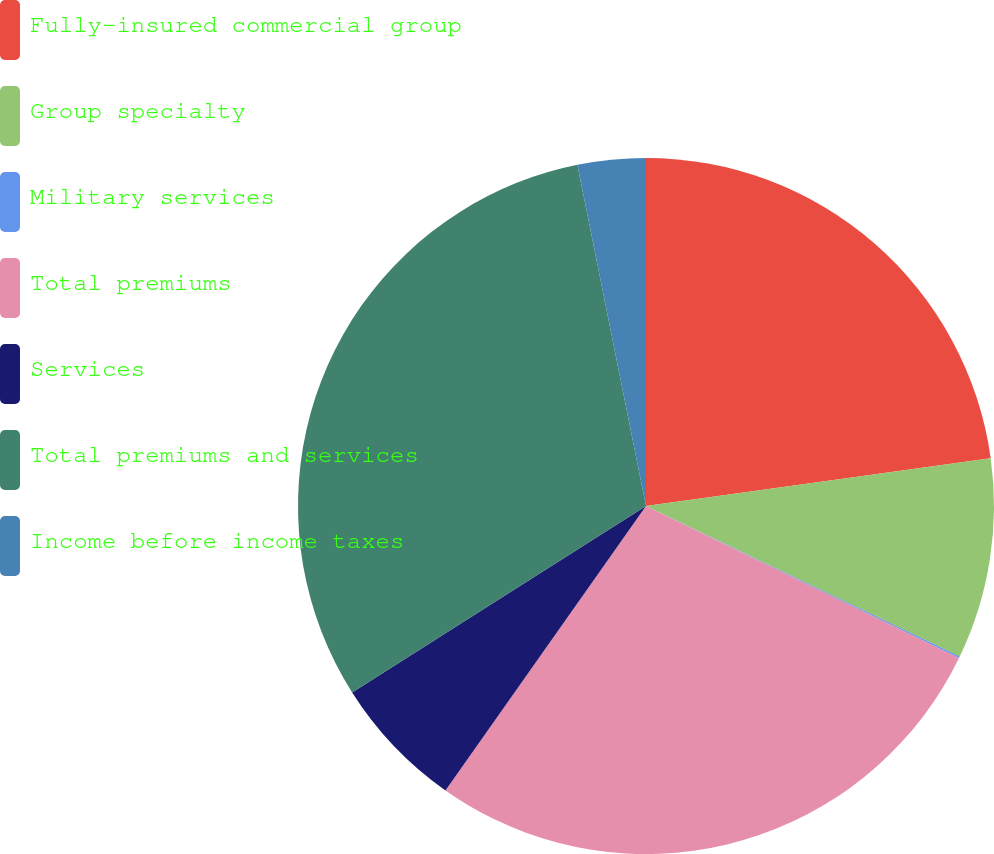<chart> <loc_0><loc_0><loc_500><loc_500><pie_chart><fcel>Fully-insured commercial group<fcel>Group specialty<fcel>Military services<fcel>Total premiums<fcel>Services<fcel>Total premiums and services<fcel>Income before income taxes<nl><fcel>22.81%<fcel>9.31%<fcel>0.08%<fcel>27.58%<fcel>6.23%<fcel>30.84%<fcel>3.16%<nl></chart> 